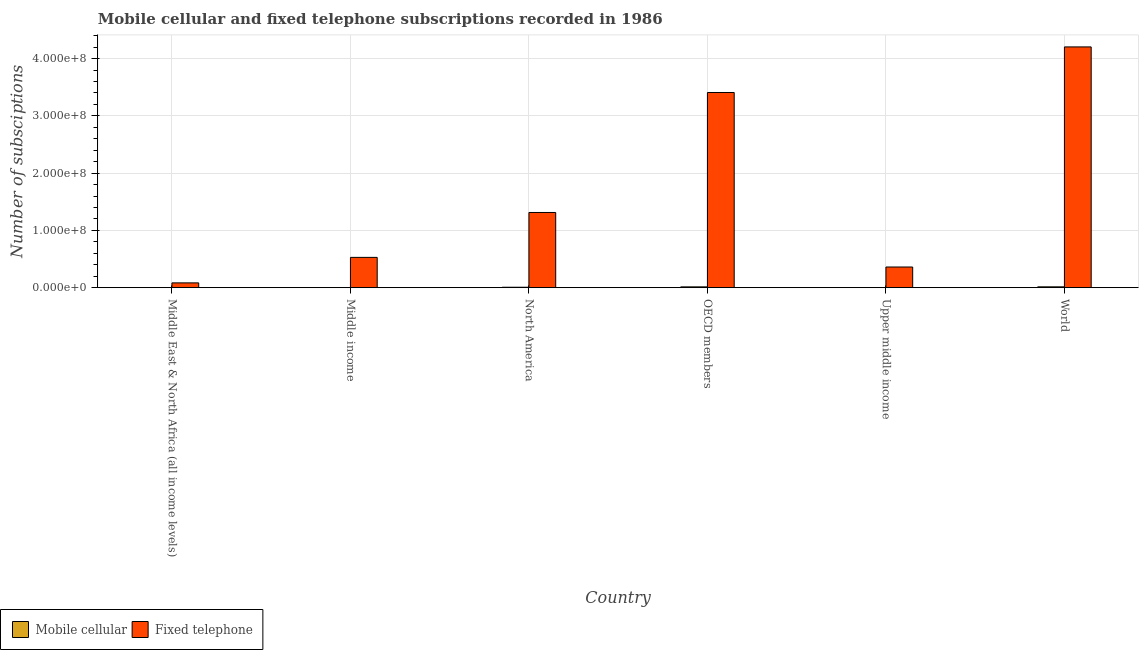How many different coloured bars are there?
Ensure brevity in your answer.  2. How many groups of bars are there?
Give a very brief answer. 6. Are the number of bars per tick equal to the number of legend labels?
Your answer should be compact. Yes. How many bars are there on the 2nd tick from the left?
Your answer should be compact. 2. What is the label of the 1st group of bars from the left?
Keep it short and to the point. Middle East & North Africa (all income levels). In how many cases, is the number of bars for a given country not equal to the number of legend labels?
Provide a succinct answer. 0. What is the number of mobile cellular subscriptions in Upper middle income?
Give a very brief answer. 1.20e+04. Across all countries, what is the maximum number of mobile cellular subscriptions?
Offer a very short reply. 1.45e+06. Across all countries, what is the minimum number of fixed telephone subscriptions?
Give a very brief answer. 8.35e+06. In which country was the number of fixed telephone subscriptions minimum?
Your answer should be very brief. Middle East & North Africa (all income levels). What is the total number of fixed telephone subscriptions in the graph?
Make the answer very short. 9.90e+08. What is the difference between the number of fixed telephone subscriptions in Middle income and that in OECD members?
Ensure brevity in your answer.  -2.88e+08. What is the difference between the number of mobile cellular subscriptions in Upper middle income and the number of fixed telephone subscriptions in World?
Give a very brief answer. -4.20e+08. What is the average number of fixed telephone subscriptions per country?
Provide a succinct answer. 1.65e+08. What is the difference between the number of mobile cellular subscriptions and number of fixed telephone subscriptions in World?
Keep it short and to the point. -4.19e+08. In how many countries, is the number of mobile cellular subscriptions greater than 340000000 ?
Make the answer very short. 0. What is the ratio of the number of fixed telephone subscriptions in Middle income to that in OECD members?
Offer a very short reply. 0.16. Is the difference between the number of mobile cellular subscriptions in Upper middle income and World greater than the difference between the number of fixed telephone subscriptions in Upper middle income and World?
Your answer should be compact. Yes. What is the difference between the highest and the second highest number of mobile cellular subscriptions?
Your response must be concise. 4.69e+04. What is the difference between the highest and the lowest number of mobile cellular subscriptions?
Give a very brief answer. 1.44e+06. In how many countries, is the number of fixed telephone subscriptions greater than the average number of fixed telephone subscriptions taken over all countries?
Ensure brevity in your answer.  2. What does the 2nd bar from the left in Middle income represents?
Provide a succinct answer. Fixed telephone. What does the 1st bar from the right in Middle East & North Africa (all income levels) represents?
Your answer should be very brief. Fixed telephone. How many bars are there?
Make the answer very short. 12. Are all the bars in the graph horizontal?
Make the answer very short. No. How many legend labels are there?
Provide a succinct answer. 2. How are the legend labels stacked?
Make the answer very short. Horizontal. What is the title of the graph?
Offer a terse response. Mobile cellular and fixed telephone subscriptions recorded in 1986. Does "Lower secondary rate" appear as one of the legend labels in the graph?
Offer a terse response. No. What is the label or title of the Y-axis?
Your answer should be compact. Number of subsciptions. What is the Number of subsciptions in Mobile cellular in Middle East & North Africa (all income levels)?
Offer a very short reply. 2.08e+04. What is the Number of subsciptions of Fixed telephone in Middle East & North Africa (all income levels)?
Offer a very short reply. 8.35e+06. What is the Number of subsciptions in Mobile cellular in Middle income?
Offer a very short reply. 1.65e+04. What is the Number of subsciptions of Fixed telephone in Middle income?
Your answer should be very brief. 5.29e+07. What is the Number of subsciptions in Mobile cellular in North America?
Make the answer very short. 7.42e+05. What is the Number of subsciptions in Fixed telephone in North America?
Offer a terse response. 1.31e+08. What is the Number of subsciptions of Mobile cellular in OECD members?
Provide a short and direct response. 1.40e+06. What is the Number of subsciptions of Fixed telephone in OECD members?
Keep it short and to the point. 3.41e+08. What is the Number of subsciptions in Mobile cellular in Upper middle income?
Your answer should be compact. 1.20e+04. What is the Number of subsciptions in Fixed telephone in Upper middle income?
Offer a very short reply. 3.61e+07. What is the Number of subsciptions in Mobile cellular in World?
Provide a succinct answer. 1.45e+06. What is the Number of subsciptions in Fixed telephone in World?
Offer a terse response. 4.20e+08. Across all countries, what is the maximum Number of subsciptions in Mobile cellular?
Your answer should be very brief. 1.45e+06. Across all countries, what is the maximum Number of subsciptions in Fixed telephone?
Give a very brief answer. 4.20e+08. Across all countries, what is the minimum Number of subsciptions of Mobile cellular?
Provide a succinct answer. 1.20e+04. Across all countries, what is the minimum Number of subsciptions of Fixed telephone?
Offer a very short reply. 8.35e+06. What is the total Number of subsciptions of Mobile cellular in the graph?
Provide a succinct answer. 3.64e+06. What is the total Number of subsciptions of Fixed telephone in the graph?
Your response must be concise. 9.90e+08. What is the difference between the Number of subsciptions in Mobile cellular in Middle East & North Africa (all income levels) and that in Middle income?
Your response must be concise. 4222. What is the difference between the Number of subsciptions in Fixed telephone in Middle East & North Africa (all income levels) and that in Middle income?
Provide a succinct answer. -4.45e+07. What is the difference between the Number of subsciptions in Mobile cellular in Middle East & North Africa (all income levels) and that in North America?
Provide a short and direct response. -7.21e+05. What is the difference between the Number of subsciptions in Fixed telephone in Middle East & North Africa (all income levels) and that in North America?
Keep it short and to the point. -1.23e+08. What is the difference between the Number of subsciptions of Mobile cellular in Middle East & North Africa (all income levels) and that in OECD members?
Ensure brevity in your answer.  -1.38e+06. What is the difference between the Number of subsciptions in Fixed telephone in Middle East & North Africa (all income levels) and that in OECD members?
Give a very brief answer. -3.32e+08. What is the difference between the Number of subsciptions of Mobile cellular in Middle East & North Africa (all income levels) and that in Upper middle income?
Keep it short and to the point. 8753. What is the difference between the Number of subsciptions in Fixed telephone in Middle East & North Africa (all income levels) and that in Upper middle income?
Offer a terse response. -2.77e+07. What is the difference between the Number of subsciptions in Mobile cellular in Middle East & North Africa (all income levels) and that in World?
Make the answer very short. -1.43e+06. What is the difference between the Number of subsciptions of Fixed telephone in Middle East & North Africa (all income levels) and that in World?
Provide a succinct answer. -4.12e+08. What is the difference between the Number of subsciptions of Mobile cellular in Middle income and that in North America?
Ensure brevity in your answer.  -7.25e+05. What is the difference between the Number of subsciptions of Fixed telephone in Middle income and that in North America?
Provide a succinct answer. -7.84e+07. What is the difference between the Number of subsciptions in Mobile cellular in Middle income and that in OECD members?
Provide a short and direct response. -1.39e+06. What is the difference between the Number of subsciptions of Fixed telephone in Middle income and that in OECD members?
Give a very brief answer. -2.88e+08. What is the difference between the Number of subsciptions of Mobile cellular in Middle income and that in Upper middle income?
Offer a very short reply. 4531. What is the difference between the Number of subsciptions in Fixed telephone in Middle income and that in Upper middle income?
Your answer should be compact. 1.68e+07. What is the difference between the Number of subsciptions of Mobile cellular in Middle income and that in World?
Keep it short and to the point. -1.43e+06. What is the difference between the Number of subsciptions in Fixed telephone in Middle income and that in World?
Ensure brevity in your answer.  -3.67e+08. What is the difference between the Number of subsciptions of Mobile cellular in North America and that in OECD members?
Ensure brevity in your answer.  -6.61e+05. What is the difference between the Number of subsciptions of Fixed telephone in North America and that in OECD members?
Keep it short and to the point. -2.10e+08. What is the difference between the Number of subsciptions of Mobile cellular in North America and that in Upper middle income?
Give a very brief answer. 7.30e+05. What is the difference between the Number of subsciptions of Fixed telephone in North America and that in Upper middle income?
Give a very brief answer. 9.52e+07. What is the difference between the Number of subsciptions of Mobile cellular in North America and that in World?
Your answer should be very brief. -7.08e+05. What is the difference between the Number of subsciptions in Fixed telephone in North America and that in World?
Offer a very short reply. -2.89e+08. What is the difference between the Number of subsciptions of Mobile cellular in OECD members and that in Upper middle income?
Provide a short and direct response. 1.39e+06. What is the difference between the Number of subsciptions in Fixed telephone in OECD members and that in Upper middle income?
Your answer should be very brief. 3.05e+08. What is the difference between the Number of subsciptions in Mobile cellular in OECD members and that in World?
Provide a succinct answer. -4.69e+04. What is the difference between the Number of subsciptions in Fixed telephone in OECD members and that in World?
Offer a terse response. -7.96e+07. What is the difference between the Number of subsciptions in Mobile cellular in Upper middle income and that in World?
Keep it short and to the point. -1.44e+06. What is the difference between the Number of subsciptions of Fixed telephone in Upper middle income and that in World?
Keep it short and to the point. -3.84e+08. What is the difference between the Number of subsciptions of Mobile cellular in Middle East & North Africa (all income levels) and the Number of subsciptions of Fixed telephone in Middle income?
Ensure brevity in your answer.  -5.28e+07. What is the difference between the Number of subsciptions of Mobile cellular in Middle East & North Africa (all income levels) and the Number of subsciptions of Fixed telephone in North America?
Your answer should be compact. -1.31e+08. What is the difference between the Number of subsciptions of Mobile cellular in Middle East & North Africa (all income levels) and the Number of subsciptions of Fixed telephone in OECD members?
Keep it short and to the point. -3.41e+08. What is the difference between the Number of subsciptions in Mobile cellular in Middle East & North Africa (all income levels) and the Number of subsciptions in Fixed telephone in Upper middle income?
Make the answer very short. -3.60e+07. What is the difference between the Number of subsciptions in Mobile cellular in Middle East & North Africa (all income levels) and the Number of subsciptions in Fixed telephone in World?
Ensure brevity in your answer.  -4.20e+08. What is the difference between the Number of subsciptions of Mobile cellular in Middle income and the Number of subsciptions of Fixed telephone in North America?
Give a very brief answer. -1.31e+08. What is the difference between the Number of subsciptions in Mobile cellular in Middle income and the Number of subsciptions in Fixed telephone in OECD members?
Ensure brevity in your answer.  -3.41e+08. What is the difference between the Number of subsciptions of Mobile cellular in Middle income and the Number of subsciptions of Fixed telephone in Upper middle income?
Your answer should be compact. -3.60e+07. What is the difference between the Number of subsciptions of Mobile cellular in Middle income and the Number of subsciptions of Fixed telephone in World?
Provide a succinct answer. -4.20e+08. What is the difference between the Number of subsciptions in Mobile cellular in North America and the Number of subsciptions in Fixed telephone in OECD members?
Make the answer very short. -3.40e+08. What is the difference between the Number of subsciptions of Mobile cellular in North America and the Number of subsciptions of Fixed telephone in Upper middle income?
Your response must be concise. -3.53e+07. What is the difference between the Number of subsciptions of Mobile cellular in North America and the Number of subsciptions of Fixed telephone in World?
Your response must be concise. -4.20e+08. What is the difference between the Number of subsciptions of Mobile cellular in OECD members and the Number of subsciptions of Fixed telephone in Upper middle income?
Provide a succinct answer. -3.46e+07. What is the difference between the Number of subsciptions of Mobile cellular in OECD members and the Number of subsciptions of Fixed telephone in World?
Your answer should be compact. -4.19e+08. What is the difference between the Number of subsciptions in Mobile cellular in Upper middle income and the Number of subsciptions in Fixed telephone in World?
Your answer should be compact. -4.20e+08. What is the average Number of subsciptions of Mobile cellular per country?
Offer a terse response. 6.07e+05. What is the average Number of subsciptions in Fixed telephone per country?
Your response must be concise. 1.65e+08. What is the difference between the Number of subsciptions of Mobile cellular and Number of subsciptions of Fixed telephone in Middle East & North Africa (all income levels)?
Your answer should be compact. -8.33e+06. What is the difference between the Number of subsciptions in Mobile cellular and Number of subsciptions in Fixed telephone in Middle income?
Keep it short and to the point. -5.28e+07. What is the difference between the Number of subsciptions in Mobile cellular and Number of subsciptions in Fixed telephone in North America?
Your answer should be compact. -1.31e+08. What is the difference between the Number of subsciptions of Mobile cellular and Number of subsciptions of Fixed telephone in OECD members?
Provide a succinct answer. -3.39e+08. What is the difference between the Number of subsciptions of Mobile cellular and Number of subsciptions of Fixed telephone in Upper middle income?
Your answer should be compact. -3.60e+07. What is the difference between the Number of subsciptions in Mobile cellular and Number of subsciptions in Fixed telephone in World?
Ensure brevity in your answer.  -4.19e+08. What is the ratio of the Number of subsciptions of Mobile cellular in Middle East & North Africa (all income levels) to that in Middle income?
Give a very brief answer. 1.26. What is the ratio of the Number of subsciptions of Fixed telephone in Middle East & North Africa (all income levels) to that in Middle income?
Your response must be concise. 0.16. What is the ratio of the Number of subsciptions in Mobile cellular in Middle East & North Africa (all income levels) to that in North America?
Your answer should be compact. 0.03. What is the ratio of the Number of subsciptions in Fixed telephone in Middle East & North Africa (all income levels) to that in North America?
Offer a terse response. 0.06. What is the ratio of the Number of subsciptions of Mobile cellular in Middle East & North Africa (all income levels) to that in OECD members?
Ensure brevity in your answer.  0.01. What is the ratio of the Number of subsciptions of Fixed telephone in Middle East & North Africa (all income levels) to that in OECD members?
Offer a terse response. 0.02. What is the ratio of the Number of subsciptions in Mobile cellular in Middle East & North Africa (all income levels) to that in Upper middle income?
Provide a succinct answer. 1.73. What is the ratio of the Number of subsciptions of Fixed telephone in Middle East & North Africa (all income levels) to that in Upper middle income?
Your answer should be very brief. 0.23. What is the ratio of the Number of subsciptions in Mobile cellular in Middle East & North Africa (all income levels) to that in World?
Offer a terse response. 0.01. What is the ratio of the Number of subsciptions in Fixed telephone in Middle East & North Africa (all income levels) to that in World?
Give a very brief answer. 0.02. What is the ratio of the Number of subsciptions of Mobile cellular in Middle income to that in North America?
Make the answer very short. 0.02. What is the ratio of the Number of subsciptions of Fixed telephone in Middle income to that in North America?
Offer a very short reply. 0.4. What is the ratio of the Number of subsciptions of Mobile cellular in Middle income to that in OECD members?
Ensure brevity in your answer.  0.01. What is the ratio of the Number of subsciptions in Fixed telephone in Middle income to that in OECD members?
Keep it short and to the point. 0.16. What is the ratio of the Number of subsciptions of Mobile cellular in Middle income to that in Upper middle income?
Your answer should be very brief. 1.38. What is the ratio of the Number of subsciptions of Fixed telephone in Middle income to that in Upper middle income?
Keep it short and to the point. 1.47. What is the ratio of the Number of subsciptions of Mobile cellular in Middle income to that in World?
Make the answer very short. 0.01. What is the ratio of the Number of subsciptions of Fixed telephone in Middle income to that in World?
Your answer should be compact. 0.13. What is the ratio of the Number of subsciptions of Mobile cellular in North America to that in OECD members?
Make the answer very short. 0.53. What is the ratio of the Number of subsciptions in Fixed telephone in North America to that in OECD members?
Ensure brevity in your answer.  0.39. What is the ratio of the Number of subsciptions in Mobile cellular in North America to that in Upper middle income?
Provide a short and direct response. 61.8. What is the ratio of the Number of subsciptions of Fixed telephone in North America to that in Upper middle income?
Provide a short and direct response. 3.64. What is the ratio of the Number of subsciptions in Mobile cellular in North America to that in World?
Ensure brevity in your answer.  0.51. What is the ratio of the Number of subsciptions of Fixed telephone in North America to that in World?
Your answer should be very brief. 0.31. What is the ratio of the Number of subsciptions of Mobile cellular in OECD members to that in Upper middle income?
Keep it short and to the point. 116.91. What is the ratio of the Number of subsciptions in Fixed telephone in OECD members to that in Upper middle income?
Provide a succinct answer. 9.45. What is the ratio of the Number of subsciptions of Mobile cellular in OECD members to that in World?
Provide a short and direct response. 0.97. What is the ratio of the Number of subsciptions of Fixed telephone in OECD members to that in World?
Make the answer very short. 0.81. What is the ratio of the Number of subsciptions of Mobile cellular in Upper middle income to that in World?
Your answer should be compact. 0.01. What is the ratio of the Number of subsciptions of Fixed telephone in Upper middle income to that in World?
Keep it short and to the point. 0.09. What is the difference between the highest and the second highest Number of subsciptions of Mobile cellular?
Provide a succinct answer. 4.69e+04. What is the difference between the highest and the second highest Number of subsciptions of Fixed telephone?
Offer a terse response. 7.96e+07. What is the difference between the highest and the lowest Number of subsciptions of Mobile cellular?
Offer a very short reply. 1.44e+06. What is the difference between the highest and the lowest Number of subsciptions in Fixed telephone?
Offer a very short reply. 4.12e+08. 